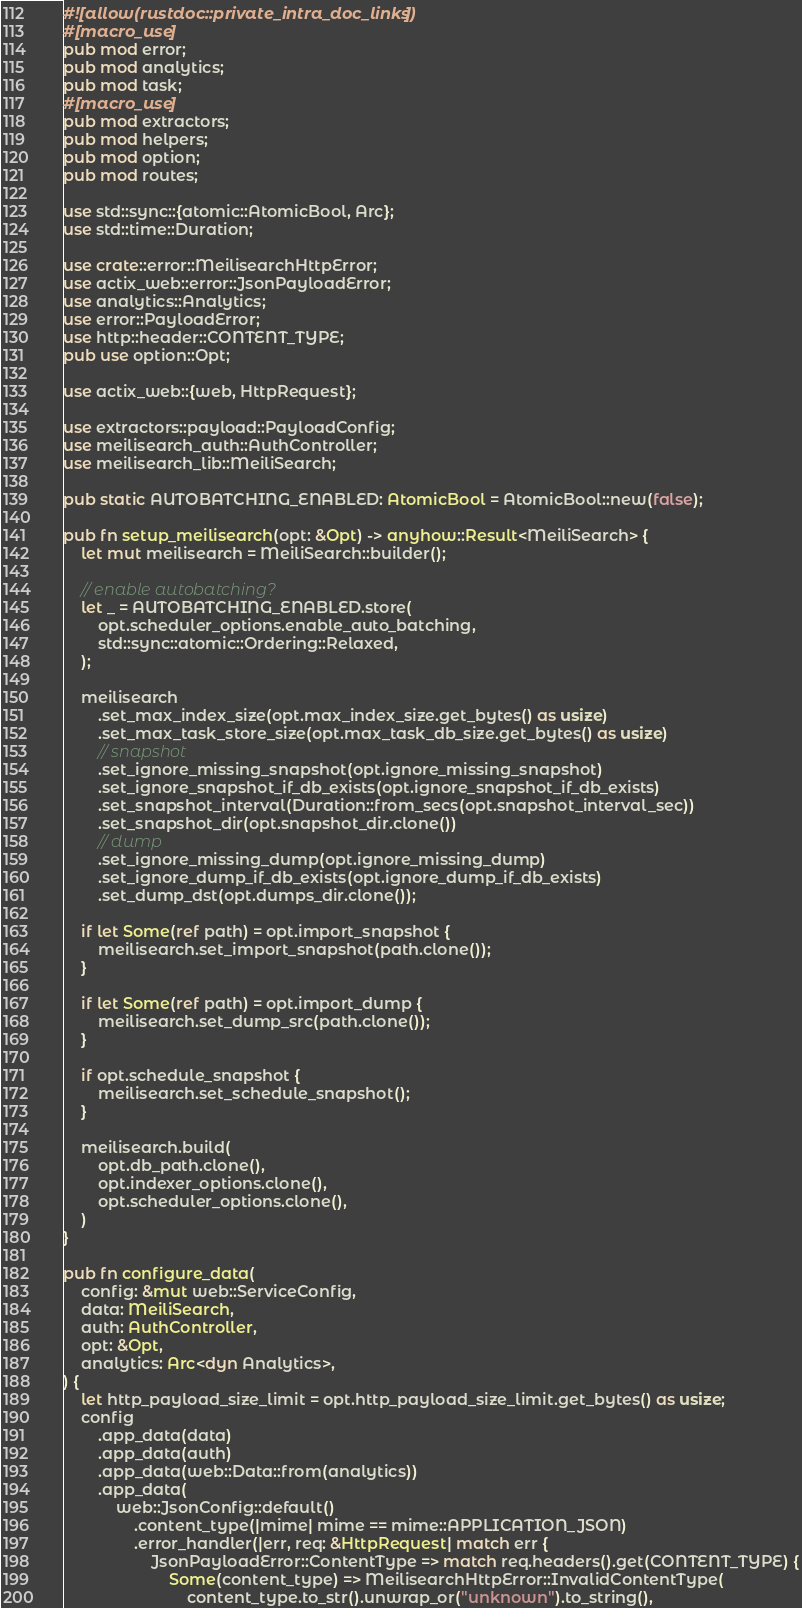Convert code to text. <code><loc_0><loc_0><loc_500><loc_500><_Rust_>#![allow(rustdoc::private_intra_doc_links)]
#[macro_use]
pub mod error;
pub mod analytics;
pub mod task;
#[macro_use]
pub mod extractors;
pub mod helpers;
pub mod option;
pub mod routes;

use std::sync::{atomic::AtomicBool, Arc};
use std::time::Duration;

use crate::error::MeilisearchHttpError;
use actix_web::error::JsonPayloadError;
use analytics::Analytics;
use error::PayloadError;
use http::header::CONTENT_TYPE;
pub use option::Opt;

use actix_web::{web, HttpRequest};

use extractors::payload::PayloadConfig;
use meilisearch_auth::AuthController;
use meilisearch_lib::MeiliSearch;

pub static AUTOBATCHING_ENABLED: AtomicBool = AtomicBool::new(false);

pub fn setup_meilisearch(opt: &Opt) -> anyhow::Result<MeiliSearch> {
    let mut meilisearch = MeiliSearch::builder();

    // enable autobatching?
    let _ = AUTOBATCHING_ENABLED.store(
        opt.scheduler_options.enable_auto_batching,
        std::sync::atomic::Ordering::Relaxed,
    );

    meilisearch
        .set_max_index_size(opt.max_index_size.get_bytes() as usize)
        .set_max_task_store_size(opt.max_task_db_size.get_bytes() as usize)
        // snapshot
        .set_ignore_missing_snapshot(opt.ignore_missing_snapshot)
        .set_ignore_snapshot_if_db_exists(opt.ignore_snapshot_if_db_exists)
        .set_snapshot_interval(Duration::from_secs(opt.snapshot_interval_sec))
        .set_snapshot_dir(opt.snapshot_dir.clone())
        // dump
        .set_ignore_missing_dump(opt.ignore_missing_dump)
        .set_ignore_dump_if_db_exists(opt.ignore_dump_if_db_exists)
        .set_dump_dst(opt.dumps_dir.clone());

    if let Some(ref path) = opt.import_snapshot {
        meilisearch.set_import_snapshot(path.clone());
    }

    if let Some(ref path) = opt.import_dump {
        meilisearch.set_dump_src(path.clone());
    }

    if opt.schedule_snapshot {
        meilisearch.set_schedule_snapshot();
    }

    meilisearch.build(
        opt.db_path.clone(),
        opt.indexer_options.clone(),
        opt.scheduler_options.clone(),
    )
}

pub fn configure_data(
    config: &mut web::ServiceConfig,
    data: MeiliSearch,
    auth: AuthController,
    opt: &Opt,
    analytics: Arc<dyn Analytics>,
) {
    let http_payload_size_limit = opt.http_payload_size_limit.get_bytes() as usize;
    config
        .app_data(data)
        .app_data(auth)
        .app_data(web::Data::from(analytics))
        .app_data(
            web::JsonConfig::default()
                .content_type(|mime| mime == mime::APPLICATION_JSON)
                .error_handler(|err, req: &HttpRequest| match err {
                    JsonPayloadError::ContentType => match req.headers().get(CONTENT_TYPE) {
                        Some(content_type) => MeilisearchHttpError::InvalidContentType(
                            content_type.to_str().unwrap_or("unknown").to_string(),</code> 